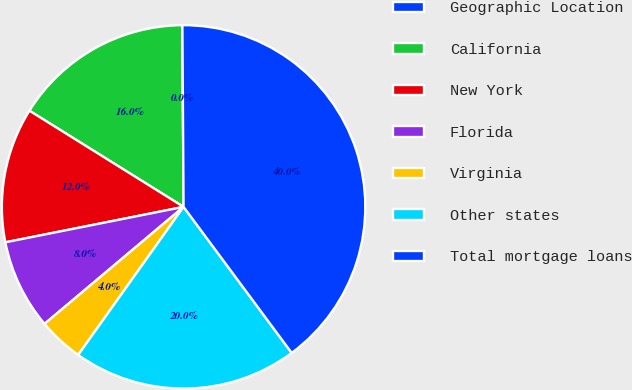<chart> <loc_0><loc_0><loc_500><loc_500><pie_chart><fcel>Geographic Location<fcel>California<fcel>New York<fcel>Florida<fcel>Virginia<fcel>Other states<fcel>Total mortgage loans<nl><fcel>0.02%<fcel>16.0%<fcel>12.0%<fcel>8.01%<fcel>4.02%<fcel>19.99%<fcel>39.96%<nl></chart> 